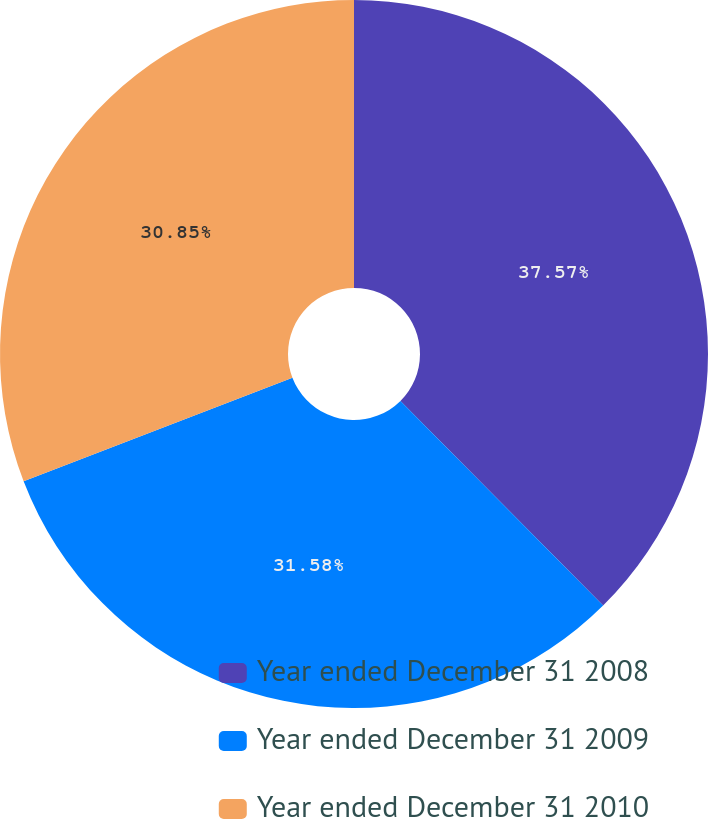<chart> <loc_0><loc_0><loc_500><loc_500><pie_chart><fcel>Year ended December 31 2008<fcel>Year ended December 31 2009<fcel>Year ended December 31 2010<nl><fcel>37.58%<fcel>31.58%<fcel>30.85%<nl></chart> 